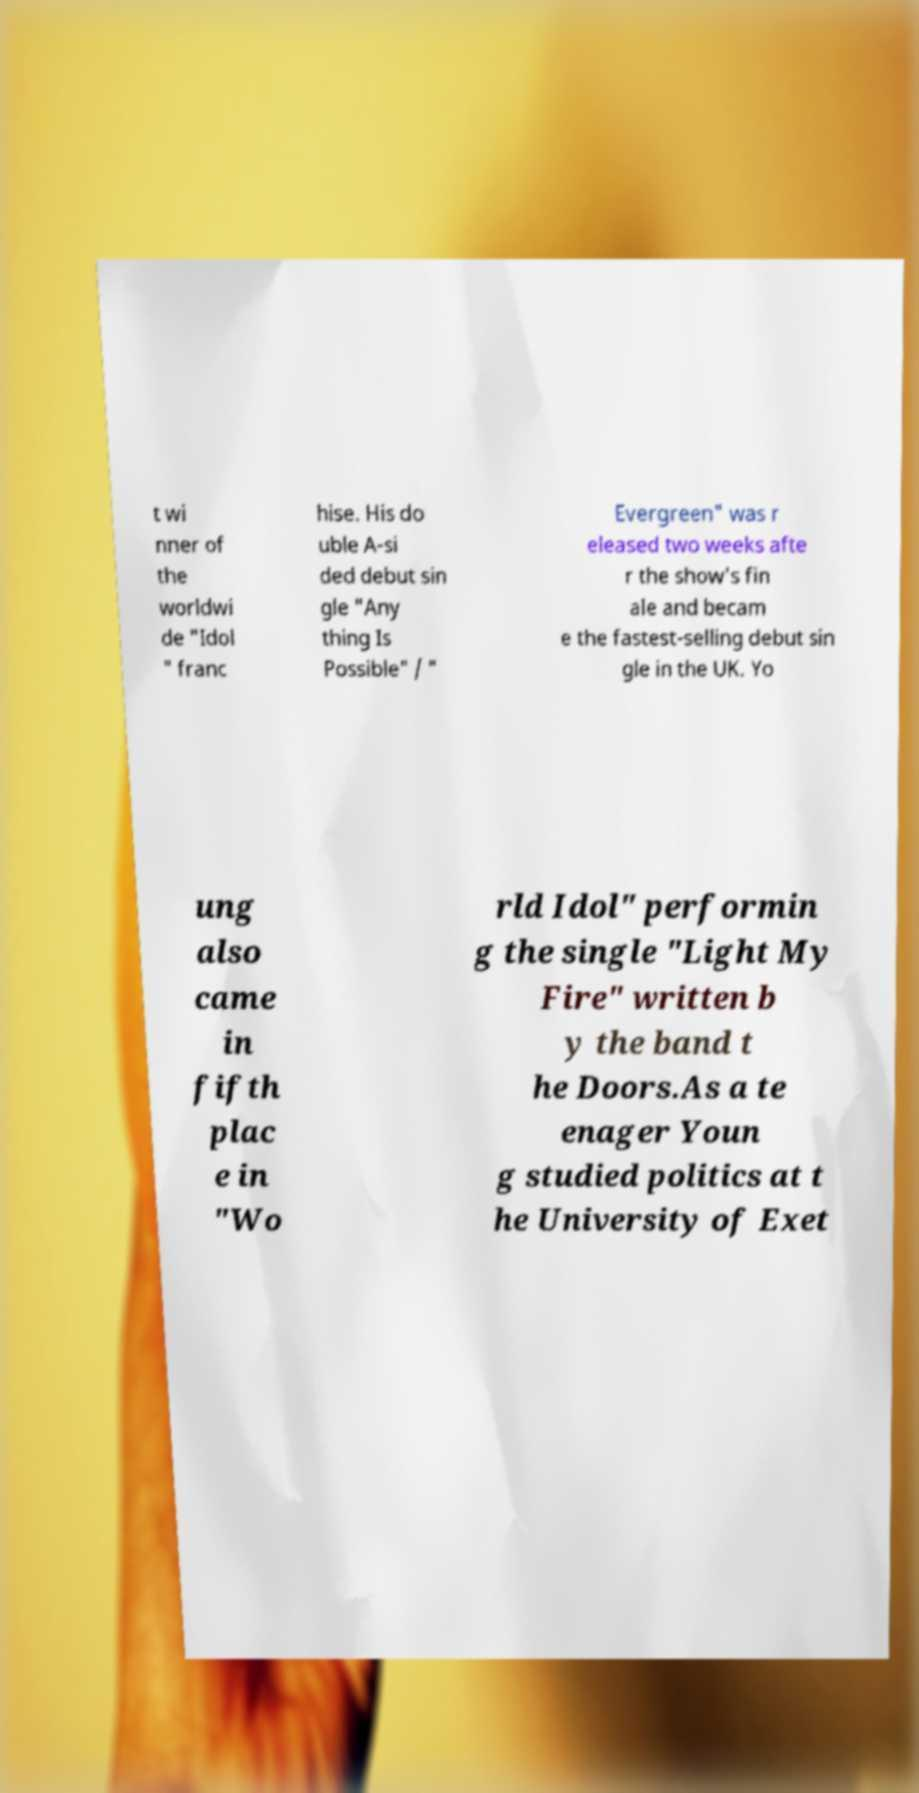Could you extract and type out the text from this image? t wi nner of the worldwi de "Idol " franc hise. His do uble A-si ded debut sin gle "Any thing Is Possible" / " Evergreen" was r eleased two weeks afte r the show's fin ale and becam e the fastest-selling debut sin gle in the UK. Yo ung also came in fifth plac e in "Wo rld Idol" performin g the single "Light My Fire" written b y the band t he Doors.As a te enager Youn g studied politics at t he University of Exet 